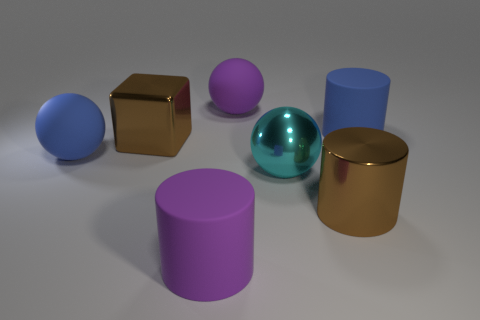Are there more big cyan things than rubber things?
Make the answer very short. No. What number of objects are either cylinders behind the cyan thing or big purple cubes?
Provide a succinct answer. 1. Are the big cyan sphere and the big brown cylinder made of the same material?
Provide a short and direct response. Yes. There is a large blue matte object that is to the right of the metallic cylinder; is its shape the same as the large matte thing that is in front of the large brown cylinder?
Keep it short and to the point. Yes. There is a brown metal cylinder; is it the same size as the blue thing that is behind the large brown cube?
Offer a very short reply. Yes. How many other objects are the same material as the purple cylinder?
Your response must be concise. 3. There is a large metal sphere that is on the right side of the cylinder that is in front of the big metallic cylinder in front of the large blue cylinder; what color is it?
Provide a succinct answer. Cyan. There is a object that is in front of the large cyan metal ball and left of the large purple ball; what is its shape?
Provide a succinct answer. Cylinder. There is a matte object that is on the right side of the metallic object that is on the right side of the cyan shiny object; what color is it?
Give a very brief answer. Blue. What is the shape of the large purple object that is on the right side of the big rubber cylinder that is in front of the large blue matte object that is in front of the shiny cube?
Your answer should be very brief. Sphere. 